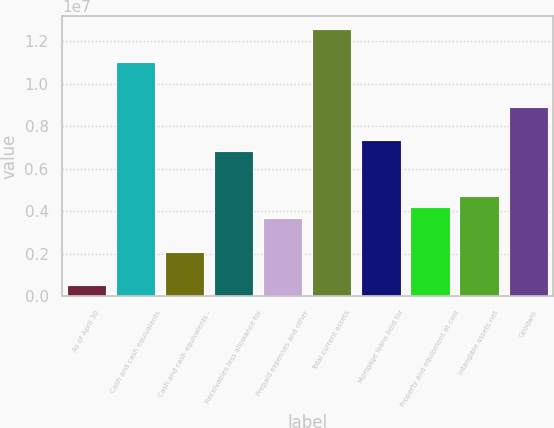<chart> <loc_0><loc_0><loc_500><loc_500><bar_chart><fcel>As of April 30<fcel>Cash and cash equivalents<fcel>Cash and cash equivalents -<fcel>Receivables less allowance for<fcel>Prepaid expenses and other<fcel>Total current assets<fcel>Mortgage loans held for<fcel>Property and equipment at cost<fcel>Intangible assets net<fcel>Goodwill<nl><fcel>524942<fcel>1.09902e+07<fcel>2.09473e+06<fcel>6.80411e+06<fcel>3.66453e+06<fcel>1.256e+07<fcel>7.32737e+06<fcel>4.18779e+06<fcel>4.71105e+06<fcel>8.89717e+06<nl></chart> 